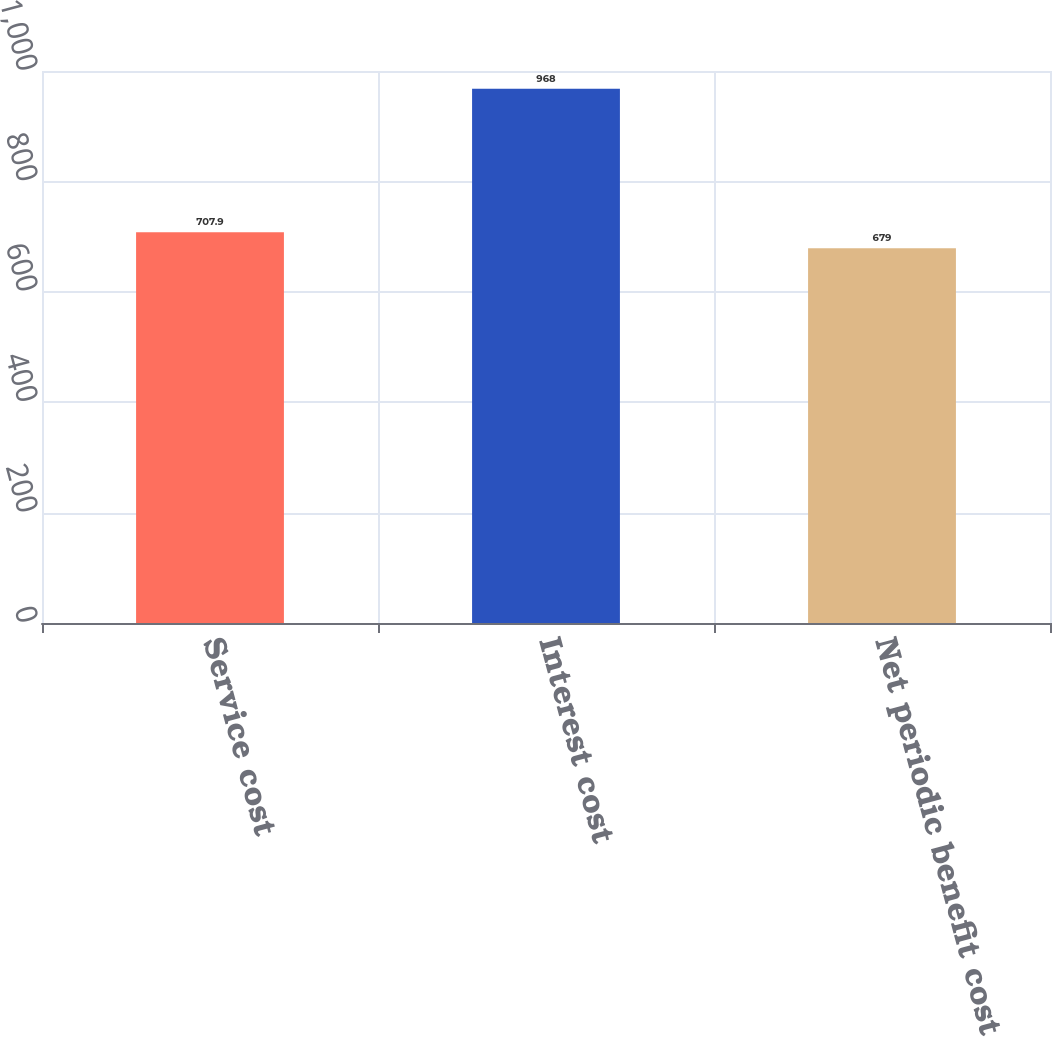<chart> <loc_0><loc_0><loc_500><loc_500><bar_chart><fcel>Service cost<fcel>Interest cost<fcel>Net periodic benefit cost<nl><fcel>707.9<fcel>968<fcel>679<nl></chart> 